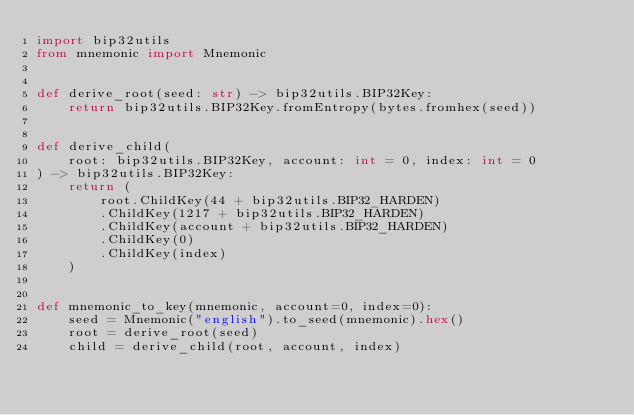<code> <loc_0><loc_0><loc_500><loc_500><_Python_>import bip32utils
from mnemonic import Mnemonic


def derive_root(seed: str) -> bip32utils.BIP32Key:
    return bip32utils.BIP32Key.fromEntropy(bytes.fromhex(seed))


def derive_child(
    root: bip32utils.BIP32Key, account: int = 0, index: int = 0
) -> bip32utils.BIP32Key:
    return (
        root.ChildKey(44 + bip32utils.BIP32_HARDEN)
        .ChildKey(1217 + bip32utils.BIP32_HARDEN)
        .ChildKey(account + bip32utils.BIP32_HARDEN)
        .ChildKey(0)
        .ChildKey(index)
    )


def mnemonic_to_key(mnemonic, account=0, index=0):
    seed = Mnemonic("english").to_seed(mnemonic).hex()
    root = derive_root(seed)
    child = derive_child(root, account, index)
</code> 